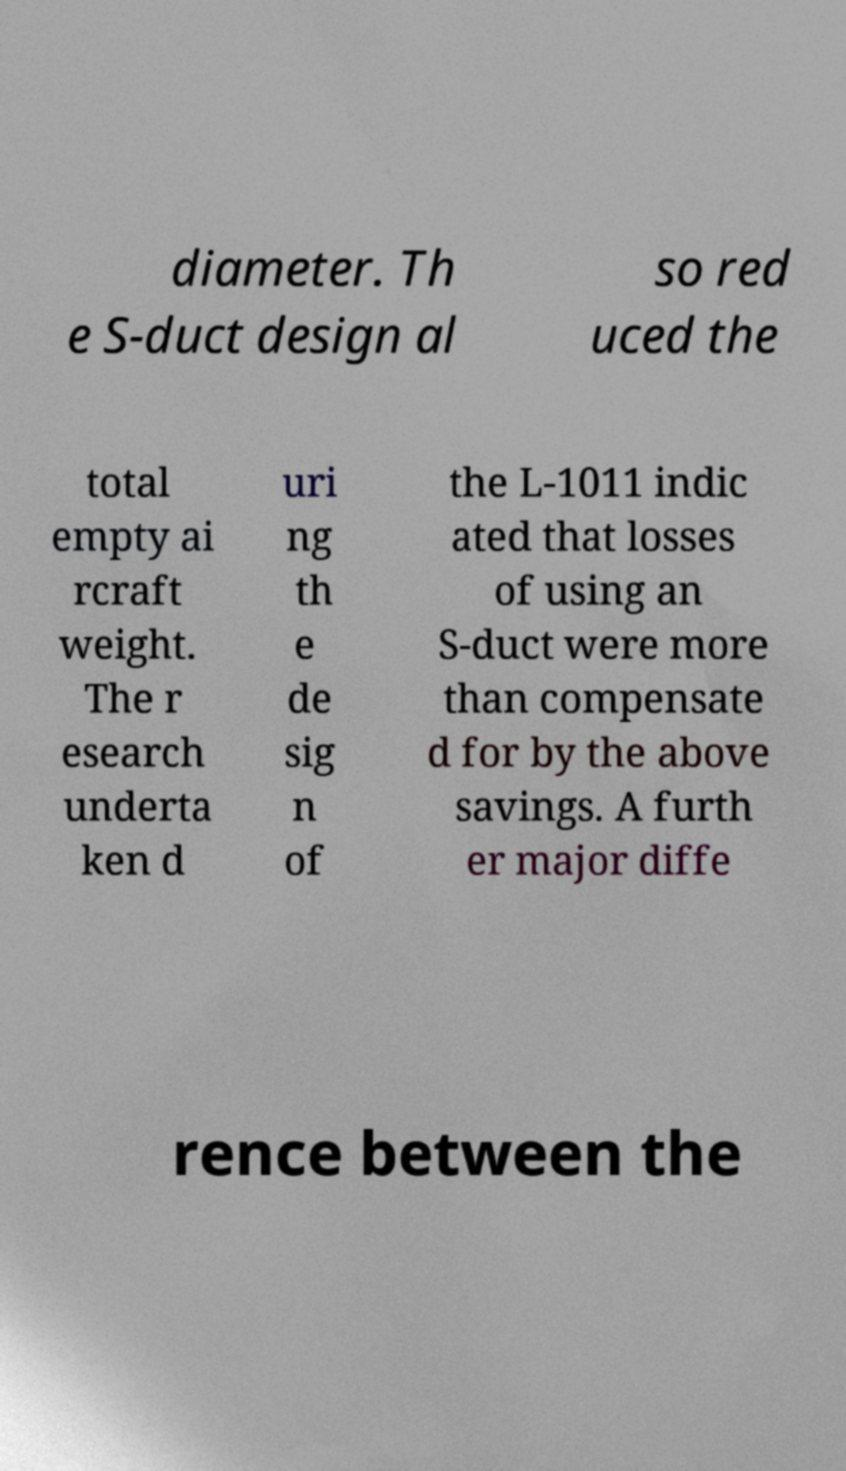Please identify and transcribe the text found in this image. diameter. Th e S-duct design al so red uced the total empty ai rcraft weight. The r esearch underta ken d uri ng th e de sig n of the L-1011 indic ated that losses of using an S-duct were more than compensate d for by the above savings. A furth er major diffe rence between the 